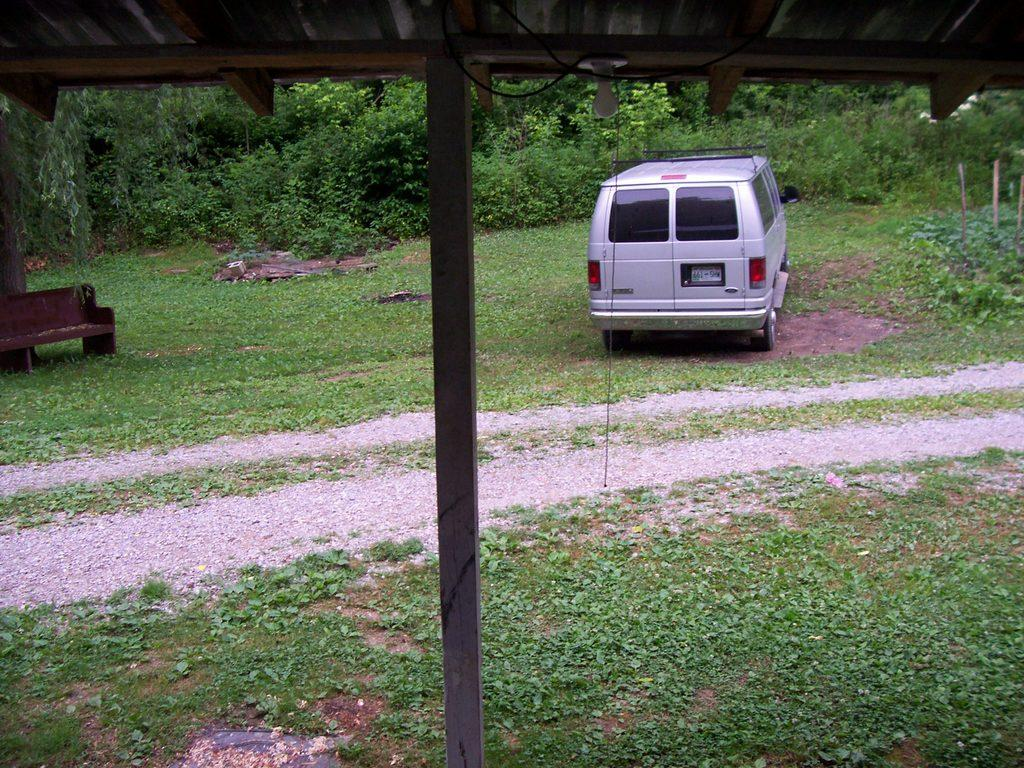What is the main object in the foreground of the image? There is a pole in the image. What is located on the roof in the image? There is a light on the roof in the image. What can be seen in the background of the image? There are trees, plants, a chair, and a vehicle in the background of the image. What type of lace is draped over the chair in the image? There is no lace present in the image; the chair is visible in the background, but no lace is draped over it. What type of meeting is taking place in the image? There is no meeting depicted in the image; it features a pole, a light, trees, plants, a chair, and a vehicle in various locations. 